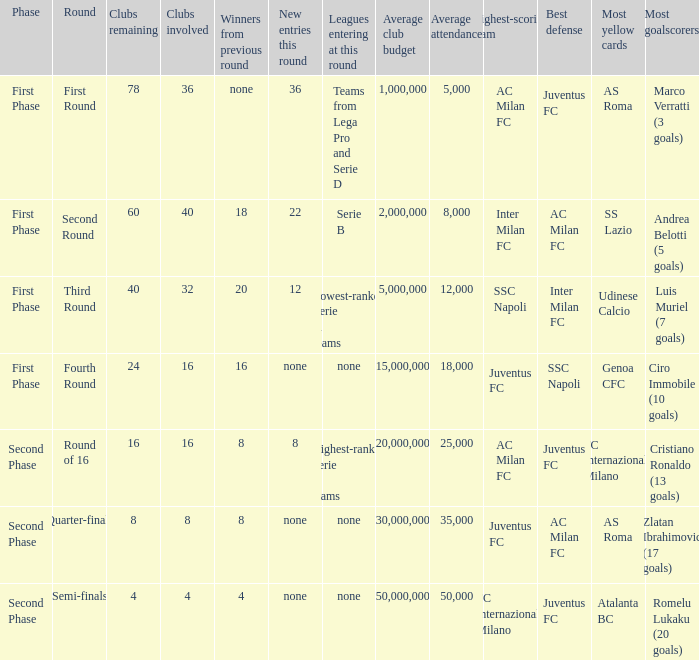When looking at new entries this round and seeing 8; what number in total is there for clubs remaining? 1.0. 